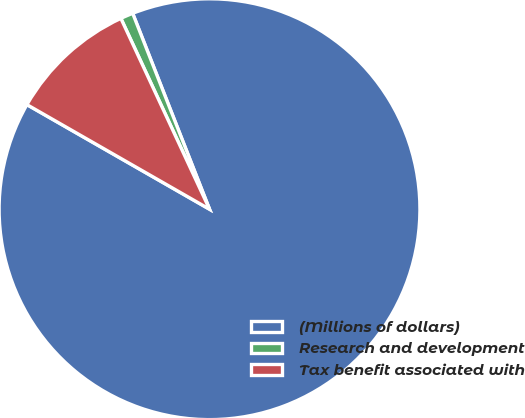<chart> <loc_0><loc_0><loc_500><loc_500><pie_chart><fcel>(Millions of dollars)<fcel>Research and development<fcel>Tax benefit associated with<nl><fcel>89.23%<fcel>0.97%<fcel>9.8%<nl></chart> 